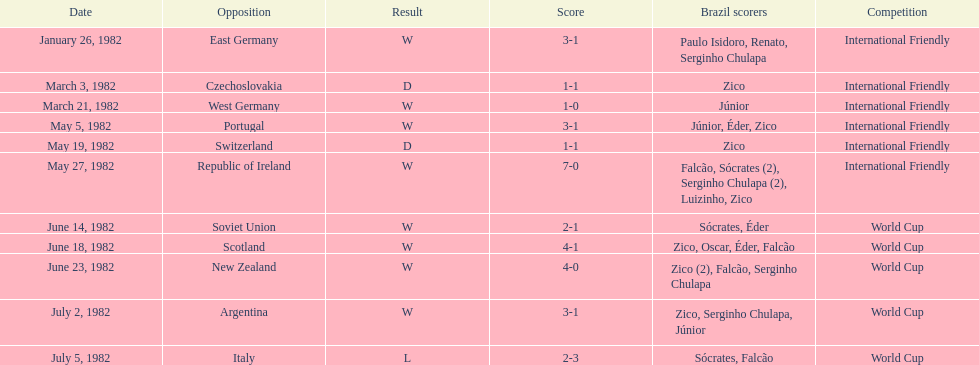During march 1982, what was the count of brazil's victories in games? 1. 